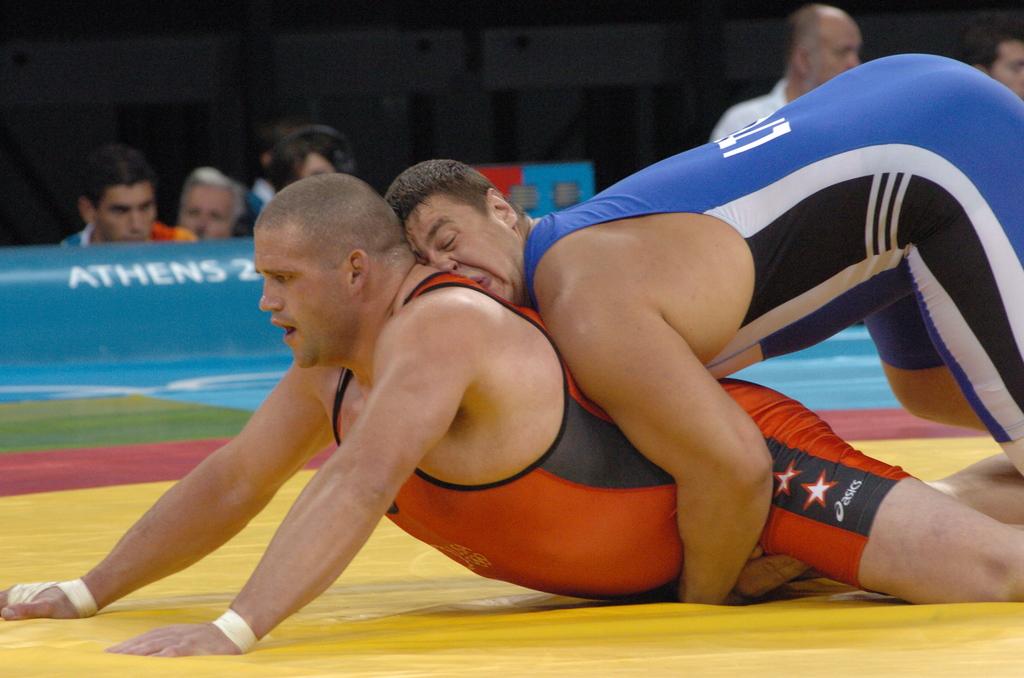What city is the wrestling match taking place?
Provide a short and direct response. Athens. What brand onsie is red wearing?
Your response must be concise. Asics. 